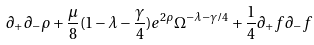Convert formula to latex. <formula><loc_0><loc_0><loc_500><loc_500>\partial _ { + } \partial _ { - } \rho + \frac { \mu } { 8 } ( 1 - \lambda - \frac { \gamma } { 4 } ) e ^ { 2 \rho } \Omega ^ { - \lambda - \gamma / 4 } + \frac { 1 } { 4 } \partial _ { + } f \partial _ { - } f</formula> 